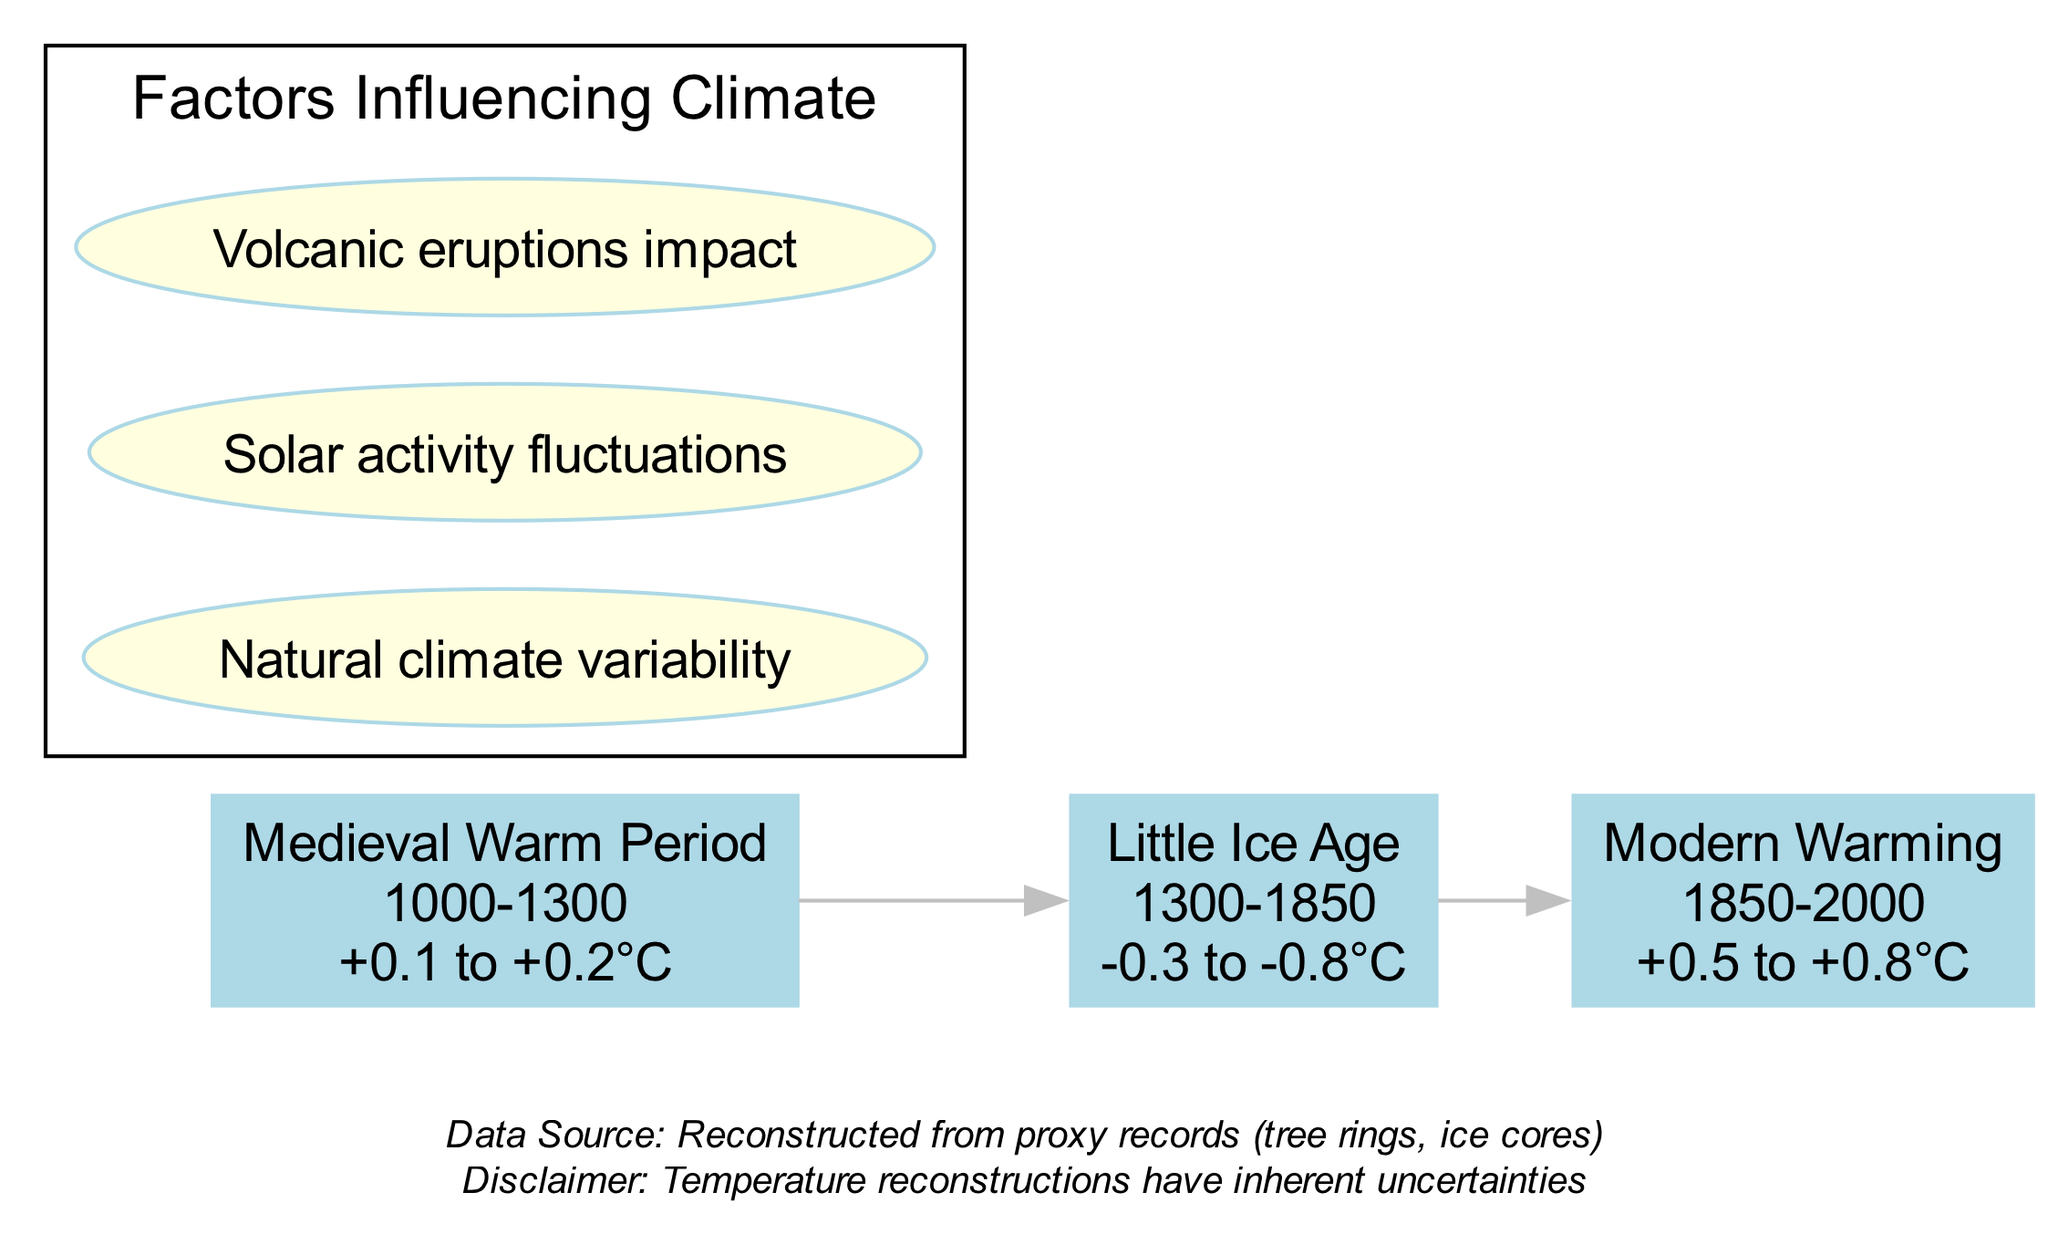What is the temperature range during the Medieval Warm Period? The diagram specifies that the temperature anomaly during the Medieval Warm Period is between +0.1 to +0.2°C. This information can be found directly in the node corresponding to this period.
Answer: +0.1 to +0.2°C How many periods are depicted in the diagram? The diagram shows a total of three distinct periods of temperature variation: the Medieval Warm Period, the Little Ice Age, and the Modern Warming. Counting each of the nodes in the diagram reveals this number.
Answer: 3 Which period had the lowest temperature anomaly? Examining the temperature ranges from each period indicates that the Little Ice Age had the lowest temperature anomaly, recorded at -0.3 to -0.8°C. This is specified in its respective node.
Answer: Little Ice Age What years did the Modern Warming span? The node for the Modern Warming period states that it lasted from 1850 to 2000, which is evident in the displayed information.
Answer: 1850-2000 What does the annotation about natural climate variability suggest? The annotation labeled "Natural climate variability" indicates an external factor that influences climate variations over time, which is positioned in the annotation section of the diagram. This suggests that factors beyond human activity can affect climate.
Answer: Natural climate variability Compare the temperature range of the Little Ice Age and Medieval Warm Period. By reading the respective temperature ranges of both periods, the Little Ice Age has a range of -0.3 to -0.8°C, while the Medieval Warm Period is +0.1 to +0.2°C. The Little Ice Age shows a significant lower range compared to the warming period.
Answer: Little Ice Age is lower What kind of data is used for the temperature reconstructions? The diagram indicates that the temperature reconstructions are "Reconstructed from proxy records (tree rings, ice cores)," which is an essential element noted at the bottom of the diagram.
Answer: Proxy records How do volcanic eruptions influence climate according to the diagram? The annotation states that "Volcanic eruptions impact" is one of the factors influencing climate, implying that such events can significantly alter temperature variations. This statement can be derived from the annotations presented in the diagram.
Answer: Volcanic eruptions impact 